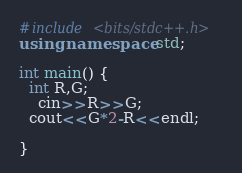<code> <loc_0><loc_0><loc_500><loc_500><_C++_>#include <bits/stdc++.h>
using namespace std;

int main() {
  int R,G;
    cin>>R>>G;
  cout<<G*2-R<<endl;
    
}</code> 